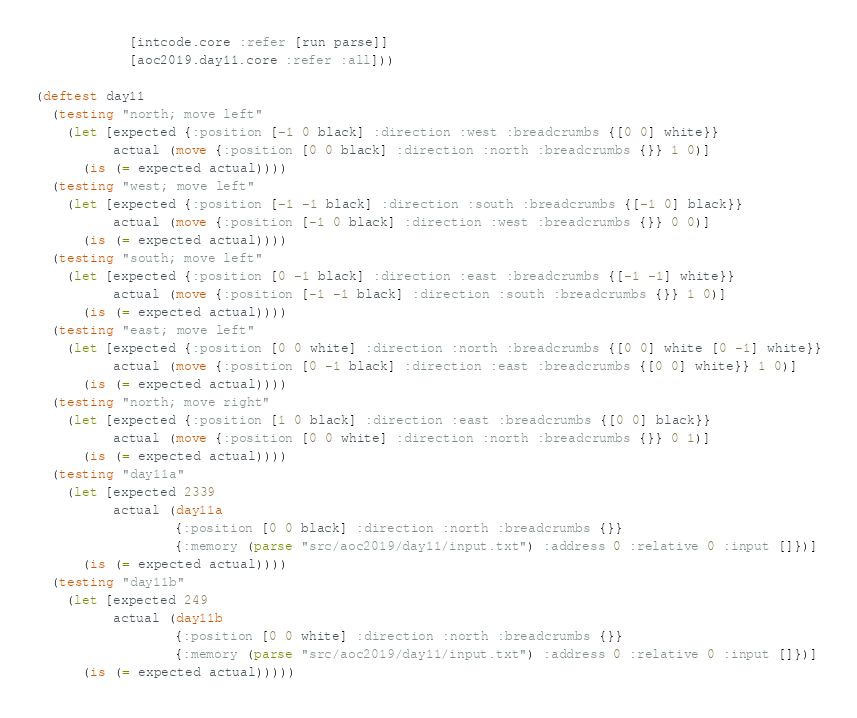Convert code to text. <code><loc_0><loc_0><loc_500><loc_500><_Clojure_>            [intcode.core :refer [run parse]]
            [aoc2019.day11.core :refer :all]))

(deftest day11
  (testing "north; move left"
    (let [expected {:position [-1 0 black] :direction :west :breadcrumbs {[0 0] white}}
          actual (move {:position [0 0 black] :direction :north :breadcrumbs {}} 1 0)]
      (is (= expected actual))))
  (testing "west; move left"
    (let [expected {:position [-1 -1 black] :direction :south :breadcrumbs {[-1 0] black}}
          actual (move {:position [-1 0 black] :direction :west :breadcrumbs {}} 0 0)]
      (is (= expected actual))))
  (testing "south; move left"
    (let [expected {:position [0 -1 black] :direction :east :breadcrumbs {[-1 -1] white}}
          actual (move {:position [-1 -1 black] :direction :south :breadcrumbs {}} 1 0)]
      (is (= expected actual))))
  (testing "east; move left"
    (let [expected {:position [0 0 white] :direction :north :breadcrumbs {[0 0] white [0 -1] white}}
          actual (move {:position [0 -1 black] :direction :east :breadcrumbs {[0 0] white}} 1 0)]
      (is (= expected actual))))
  (testing "north; move right"
    (let [expected {:position [1 0 black] :direction :east :breadcrumbs {[0 0] black}}
          actual (move {:position [0 0 white] :direction :north :breadcrumbs {}} 0 1)]
      (is (= expected actual))))
  (testing "day11a"
    (let [expected 2339
          actual (day11a
                  {:position [0 0 black] :direction :north :breadcrumbs {}}
                  {:memory (parse "src/aoc2019/day11/input.txt") :address 0 :relative 0 :input []})]
      (is (= expected actual))))
  (testing "day11b"
    (let [expected 249
          actual (day11b
                  {:position [0 0 white] :direction :north :breadcrumbs {}}
                  {:memory (parse "src/aoc2019/day11/input.txt") :address 0 :relative 0 :input []})]
      (is (= expected actual)))))</code> 